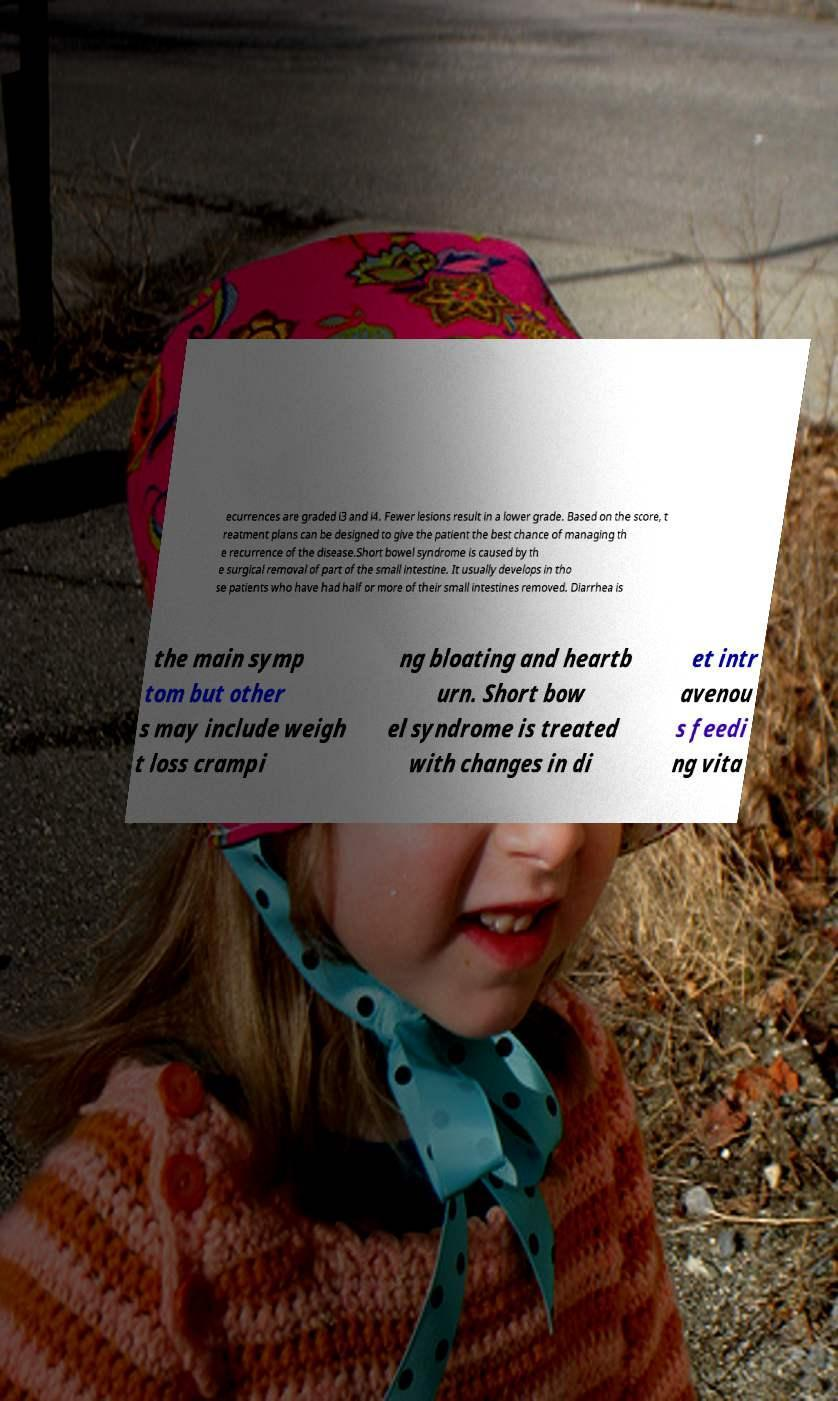Please read and relay the text visible in this image. What does it say? ecurrences are graded i3 and i4. Fewer lesions result in a lower grade. Based on the score, t reatment plans can be designed to give the patient the best chance of managing th e recurrence of the disease.Short bowel syndrome is caused by th e surgical removal of part of the small intestine. It usually develops in tho se patients who have had half or more of their small intestines removed. Diarrhea is the main symp tom but other s may include weigh t loss crampi ng bloating and heartb urn. Short bow el syndrome is treated with changes in di et intr avenou s feedi ng vita 